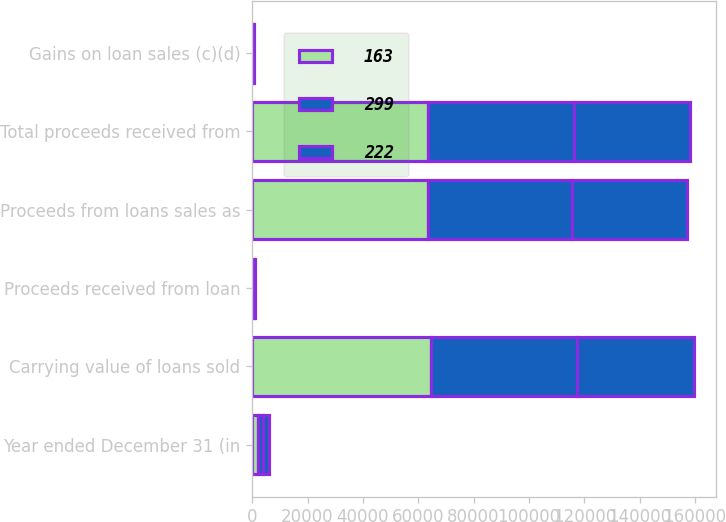Convert chart. <chart><loc_0><loc_0><loc_500><loc_500><stacked_bar_chart><ecel><fcel>Year ended December 31 (in<fcel>Carrying value of loans sold<fcel>Proceeds received from loan<fcel>Proceeds from loans sales as<fcel>Total proceeds received from<fcel>Gains on loan sales (c)(d)<nl><fcel>163<fcel>2017<fcel>64542<fcel>117<fcel>63542<fcel>63659<fcel>163<nl><fcel>299<fcel>2016<fcel>52869<fcel>592<fcel>51852<fcel>52444<fcel>222<nl><fcel>222<fcel>2015<fcel>42161<fcel>313<fcel>41615<fcel>41928<fcel>299<nl></chart> 